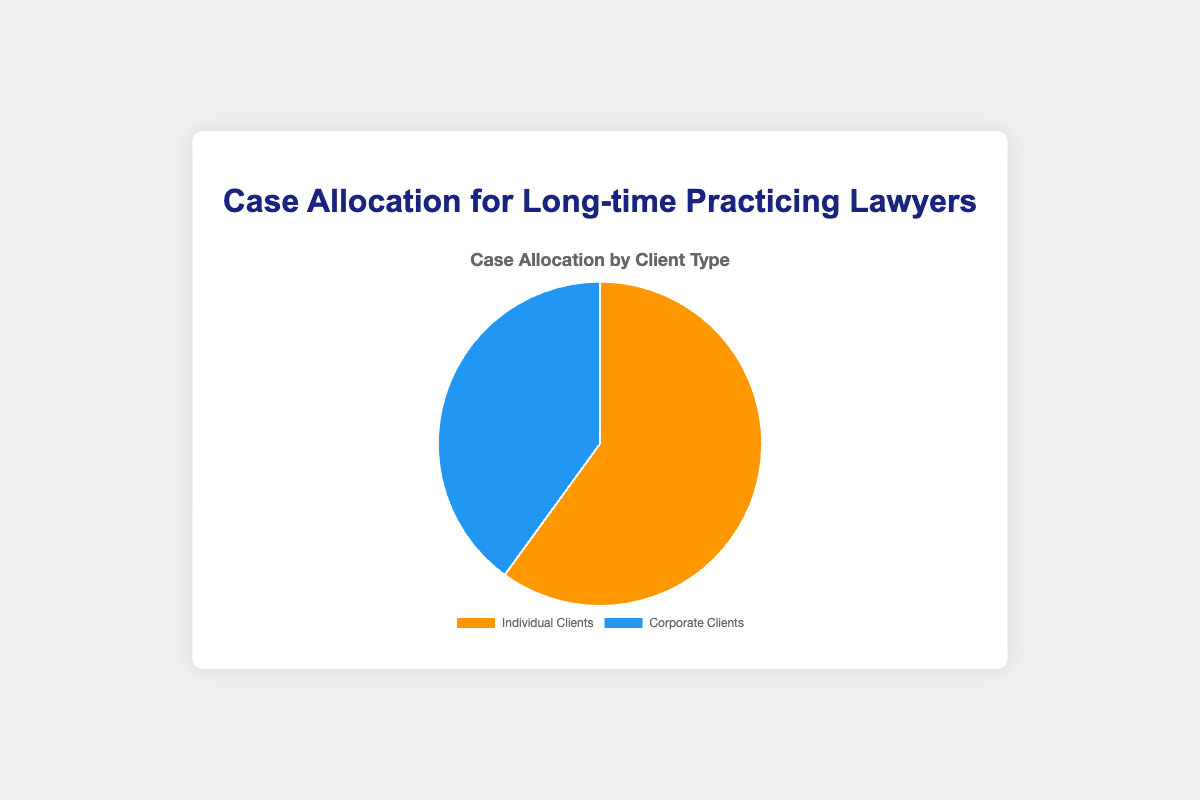what percentage of cases is allocated to individual clients? The pie chart shows that 60% of the cases are allocated to individual clients.
Answer: 60% what is the percentage difference between individual and corporate clients? The percentage of cases allocated to individual clients is 60%, and corporate clients is 40%. The difference is 60% - 40% = 20%.
Answer: 20% what is the ratio of individual client cases to corporate client cases? The percentage of cases for individual clients is 60%, and for corporate clients, it is 40%. The ratio is 60:40, which simplifies to 3:2.
Answer: 3:2 which client type has a larger share of cases, and by how much? Individual clients have a larger share of cases (60%) compared to corporate clients (40%). The difference is 60% - 40% = 20%.
Answer: Individual clients; 20% how many types of clients are represented in the pie chart, and what are they? There are two types of clients represented in the pie chart: individual clients and corporate clients.
Answer: Two; individual clients, corporate clients if a lawyer managed 100 cases, how many of these cases would likely be for corporate clients based on the chart? According to the chart, 40% of the cases are for corporate clients. Therefore, out of 100 cases, 100 * 0.40 = 40 cases would be for corporate clients.
Answer: 40 which color represents corporate clients in the pie chart? The pie chart uses blue to represent corporate clients.
Answer: Blue if an additional 10% of cases were allocated to corporate clients, what would the new percentages be for each client type? Originally, individual clients have 60% and corporate clients 40%. Adding 10% to corporate clients makes it 50%. Therefore, individual clients' share would reduce by 10%, making it 50%.
Answer: Individual clients: 50%, Corporate clients: 50% is the percentage of cases allocated to corporate clients greater than or less than half of the total cases? The percentage of cases allocated to corporate clients is 40%, which is less than half (50%) of the total cases.
Answer: Less than half if a lawyer wants to balance the diversity of their cases equally between individual and corporate clients, how should they adjust their current case allocation? Currently, cases are allocated 60% to individual clients and 40% to corporate clients. To balance it equally, both should be adjusted to 50%. This means shifting 10% from individual clients to corporate clients.
Answer: Adjust to 50% each 